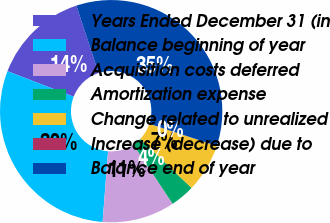Convert chart. <chart><loc_0><loc_0><loc_500><loc_500><pie_chart><fcel>Years Ended December 31 (in<fcel>Balance beginning of year<fcel>Acquisition costs deferred<fcel>Amortization expense<fcel>Change related to unrealized<fcel>Increase (decrease) due to<fcel>Balance end of year<nl><fcel>14.07%<fcel>29.64%<fcel>10.56%<fcel>3.54%<fcel>7.05%<fcel>0.03%<fcel>35.13%<nl></chart> 